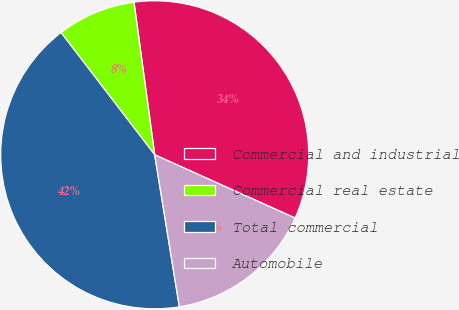<chart> <loc_0><loc_0><loc_500><loc_500><pie_chart><fcel>Commercial and industrial<fcel>Commercial real estate<fcel>Total commercial<fcel>Automobile<nl><fcel>33.88%<fcel>8.26%<fcel>42.15%<fcel>15.7%<nl></chart> 